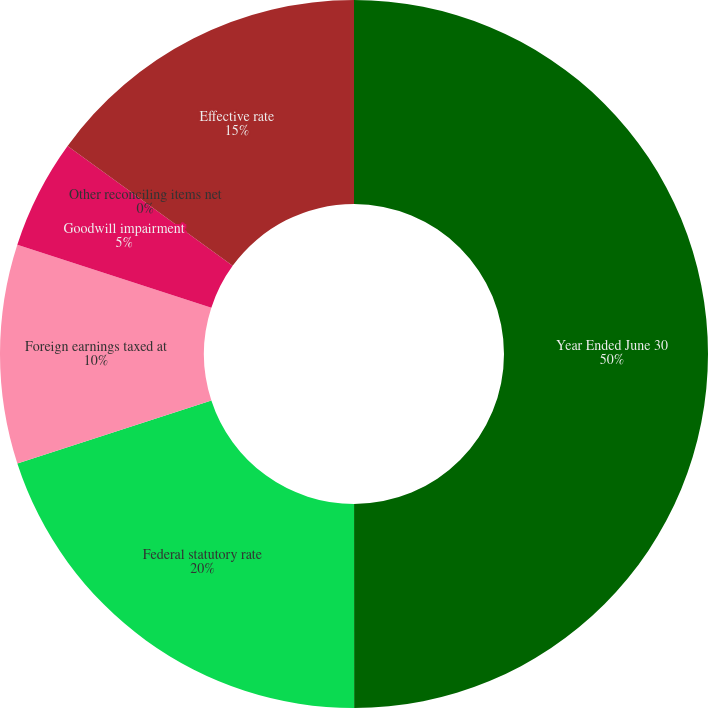Convert chart to OTSL. <chart><loc_0><loc_0><loc_500><loc_500><pie_chart><fcel>Year Ended June 30<fcel>Federal statutory rate<fcel>Foreign earnings taxed at<fcel>Goodwill impairment<fcel>Other reconciling items net<fcel>Effective rate<nl><fcel>49.99%<fcel>20.0%<fcel>10.0%<fcel>5.0%<fcel>0.0%<fcel>15.0%<nl></chart> 